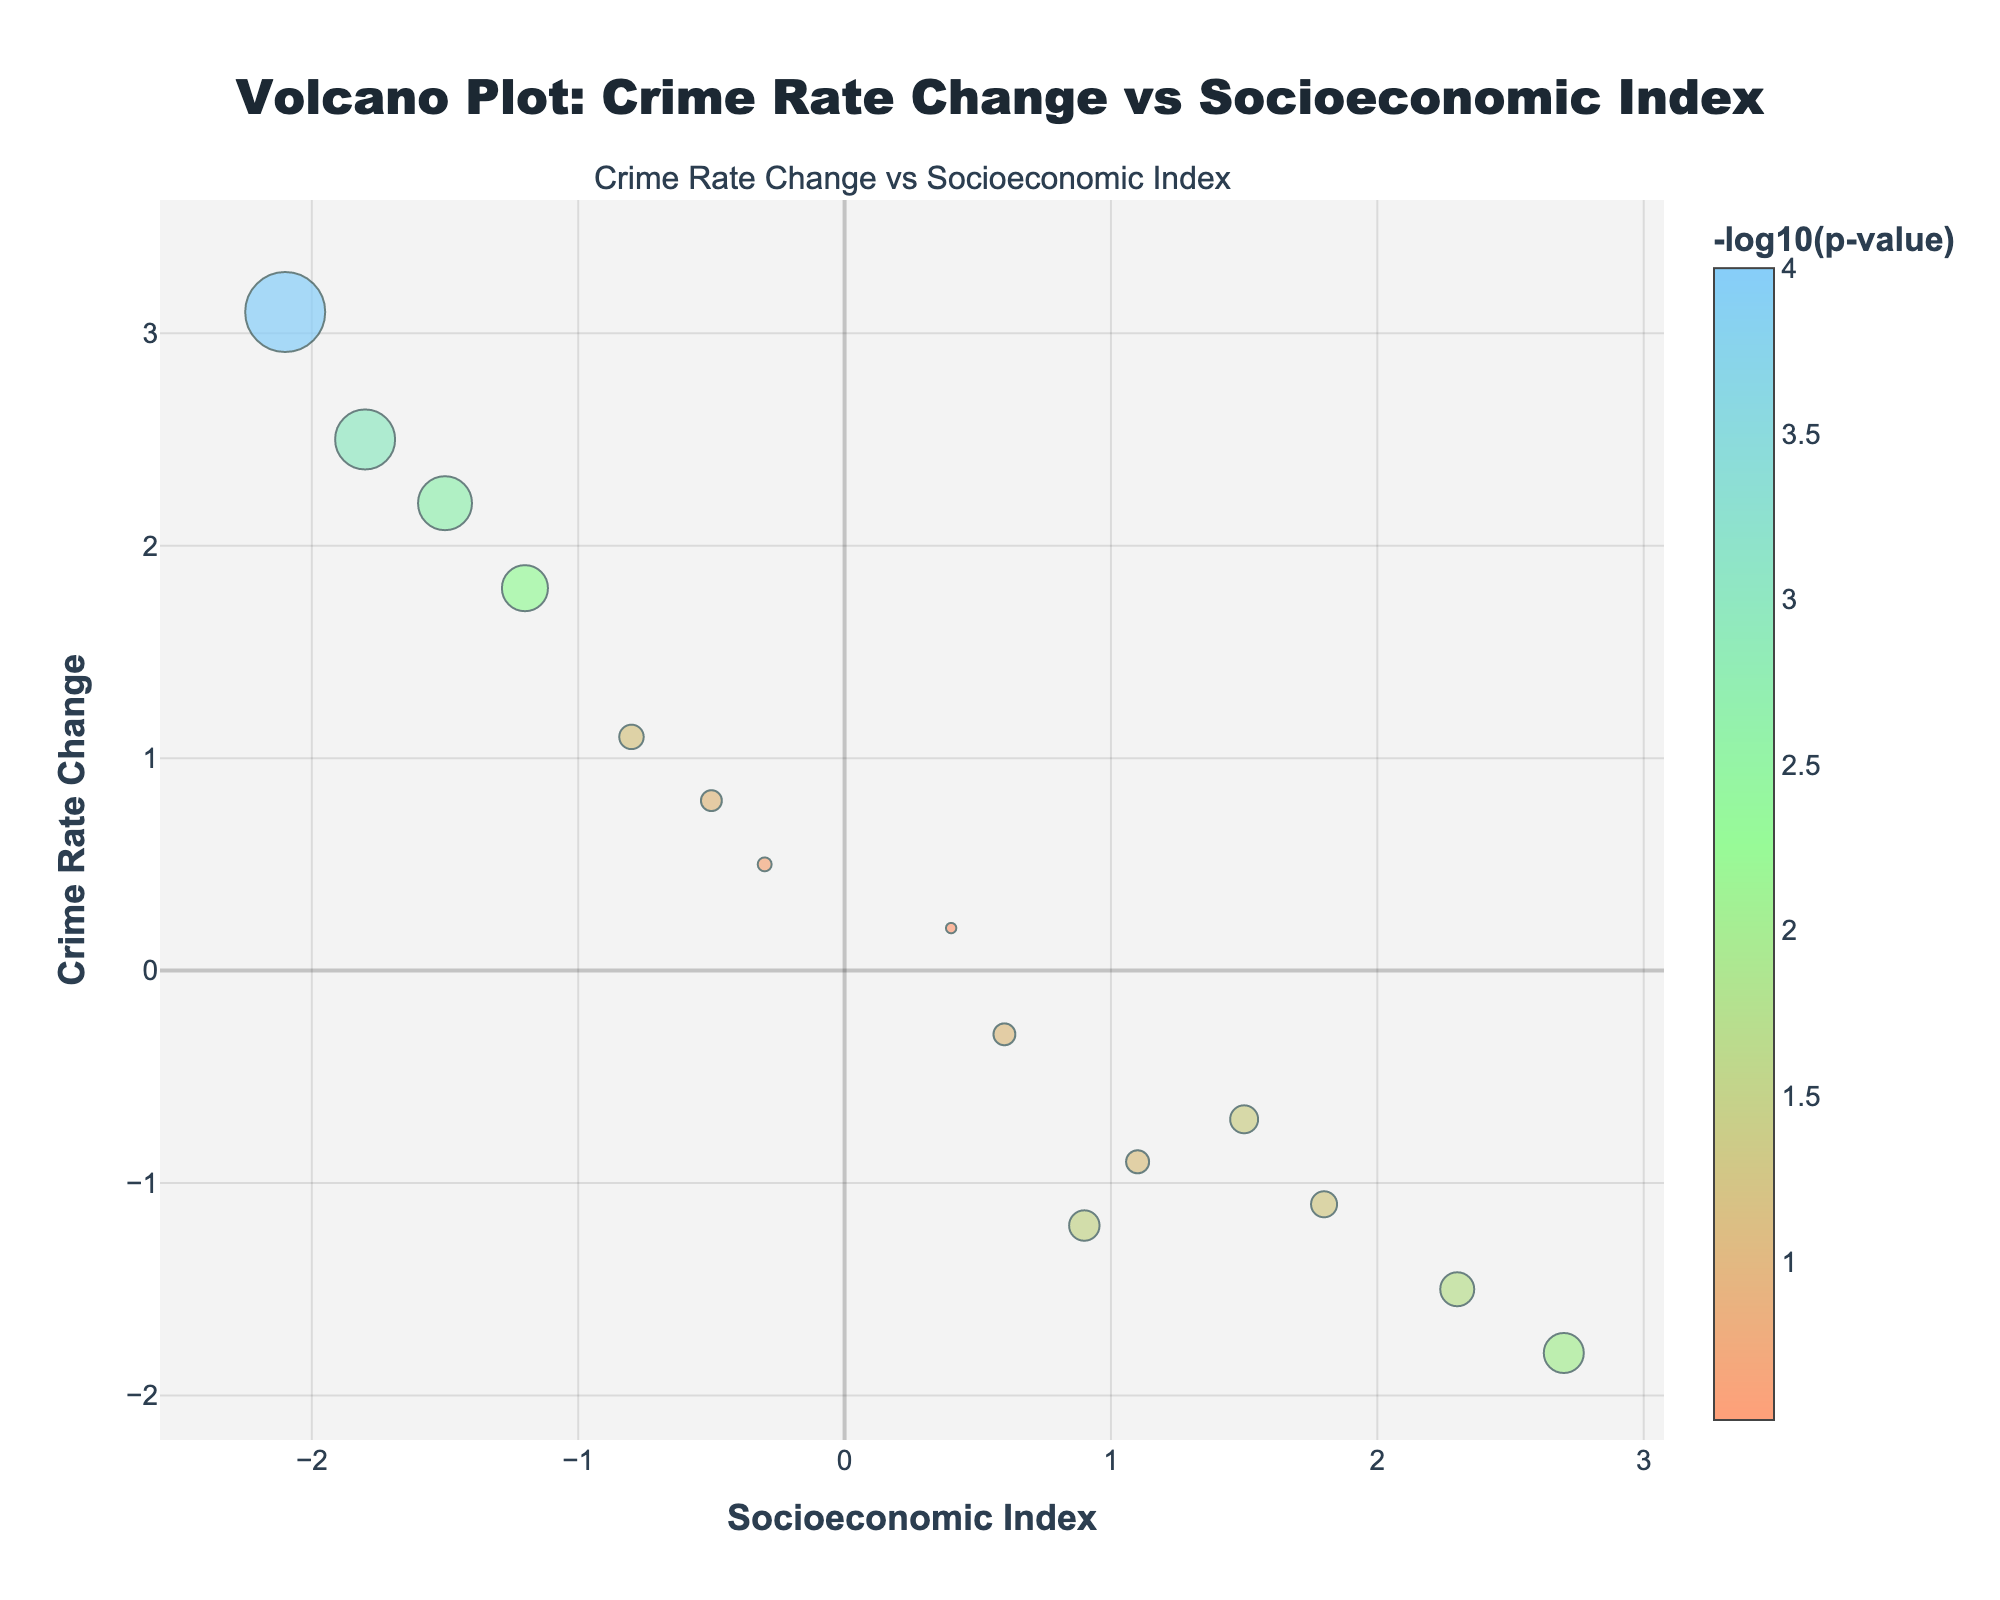What's the relationship between the Crime Rate Change and the Socioeconomic Index? The figure shows a scatter distribution where each marker's position on the x-axis represents the Socioeconomic Index and the position on the y-axis represents the Crime Rate Change. The relationship can be observed in the way these points are spread across the plot.
Answer: The relationship is scattered; no clear linear trend Which districts have the highest increase in crime rate change? To determine this, we need to look at the highest points on the y-axis which represent the crime rate change. From the figure, Harlem and Bronx are the highest points on the y-axis, indicating the highest increases in crime rate change.
Answer: Harlem and Bronx Which districts have the most significant decrease in crime rate change? We need to look at the lowest points on the y-axis which represent the decrease in crime rate. From the figure, Tribeca and Upper East Side are the lowest points on the y-axis, indicating significant decreases in crime rate change.
Answer: Tribeca and Upper East Side What does the bubble size represent in the plot? The size of each bubble is determined by the -log10(p-value) representing the statistical significance of the data points. More significant p-values result in larger bubbles.
Answer: Statistical significance How many districts have a Socioeconomic Index greater than 1.0? To find this, we count the number of markers to the right of the threshold x=1.0 on the x-axis. Looking at the plot, Manhattan, Upper East Side, Financial District, Chelsea, Tribeca, and Queens are the districts meeting this criterion.
Answer: Six districts Which districts have a statistically significant crime rate change (p < 0.05) and what does this imply? A p-value of less than 0.05 indicates a statistically significant crime rate change. From the bubble sizes, Harlem, Bronx, Brooklyn, Washington Heights, Upper East Side, and Tribeca have significant crime rate changes. Larger bubbles imply stronger statistical significance.
Answer: Harlem, Bronx, Brooklyn, Washington Heights, Upper East Side, Tribeca Compare the crime rate change between Harlem and Chelsea; which one has a higher rate and how much higher? To compare, we look at the y-axis values for Harlem and Chelsea. Harlem has a higher crime rate change of 3.1 whereas Chelsea has -0.9. The difference is calculated as 3.1 - (-0.9) = 4.0.
Answer: Harlem by 4.0 Which district appears to have a high socioeconomic index but a low crime rate change? We need to find the marker positioned high on the x-axis and low on the y-axis. The district that fits this description is Tribeca, with a Socioeconomic Index of 2.7 and a Crime Rate Change of -1.8.
Answer: Tribeca What is the color gradient used in the figure and what does it imply? The color gradient ranges from a light hue to a darker hue, corresponding to increasing -log10(p-value). This means lighter colors represent less statistically significant points, while darker colors indicate more statistically significant points.
Answer: Indicates statistical significance 